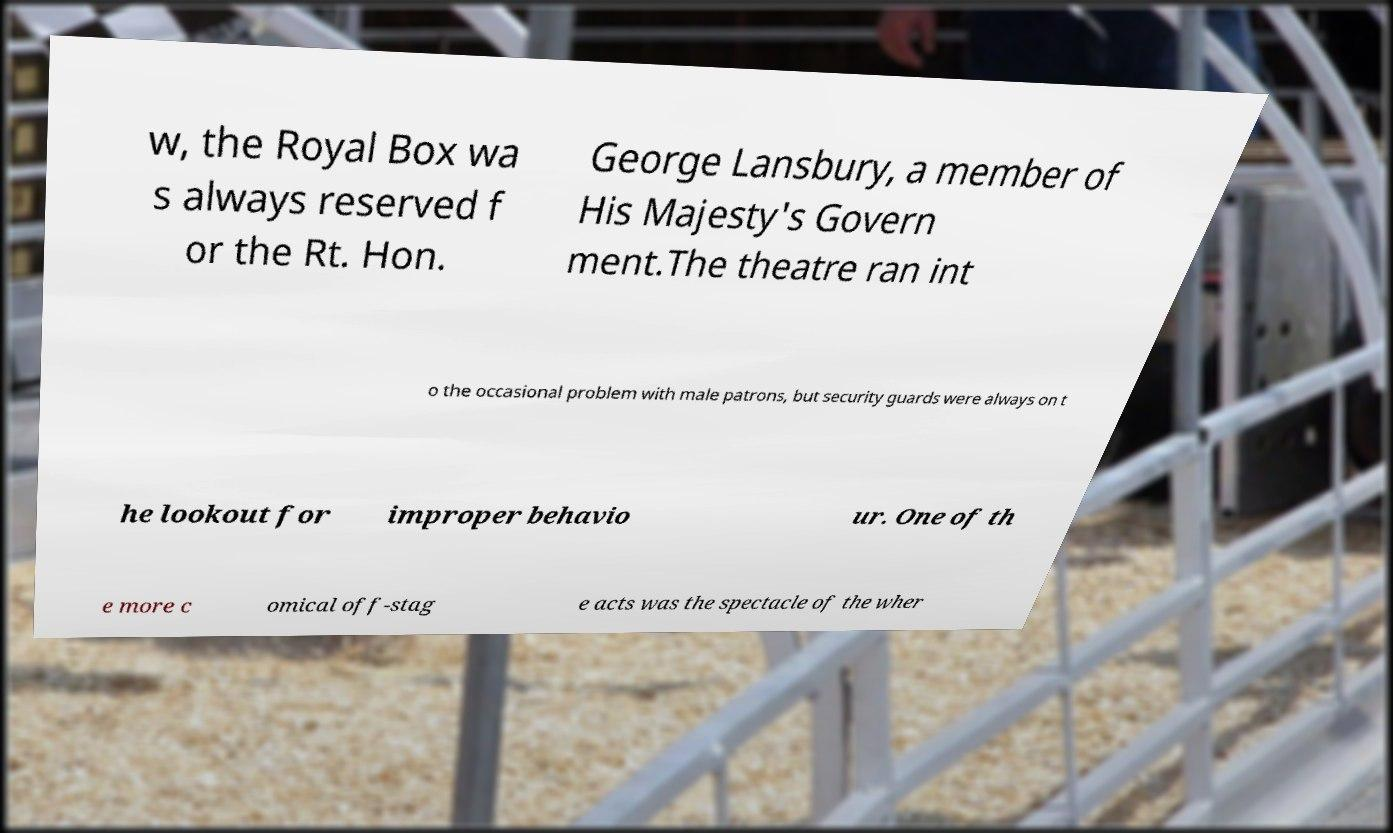Could you extract and type out the text from this image? w, the Royal Box wa s always reserved f or the Rt. Hon. George Lansbury, a member of His Majesty's Govern ment.The theatre ran int o the occasional problem with male patrons, but security guards were always on t he lookout for improper behavio ur. One of th e more c omical off-stag e acts was the spectacle of the wher 